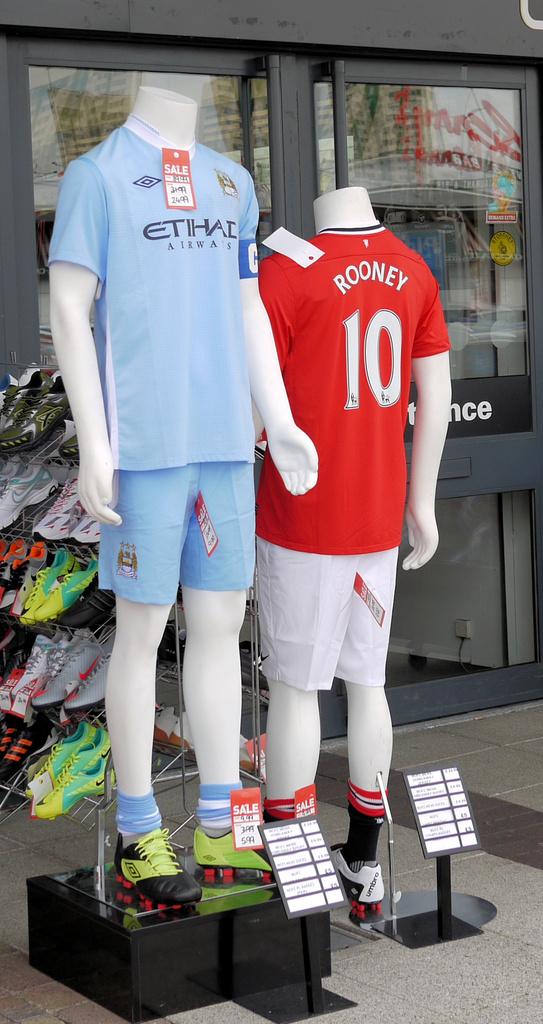What number is on the red t-shirt?
Provide a short and direct response. 10. What is the name #10?
Keep it short and to the point. Rooney. 